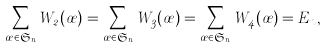Convert formula to latex. <formula><loc_0><loc_0><loc_500><loc_500>\sum _ { \sigma \in \mathfrak { S } _ { n } } W _ { 2 } ( \sigma ) = \sum _ { \sigma \in \mathfrak { S } _ { n } } W _ { 3 } ( \sigma ) = \sum _ { \sigma \in \mathfrak { S } _ { n } } W _ { 4 } ( \sigma ) = E _ { n } ,</formula> 